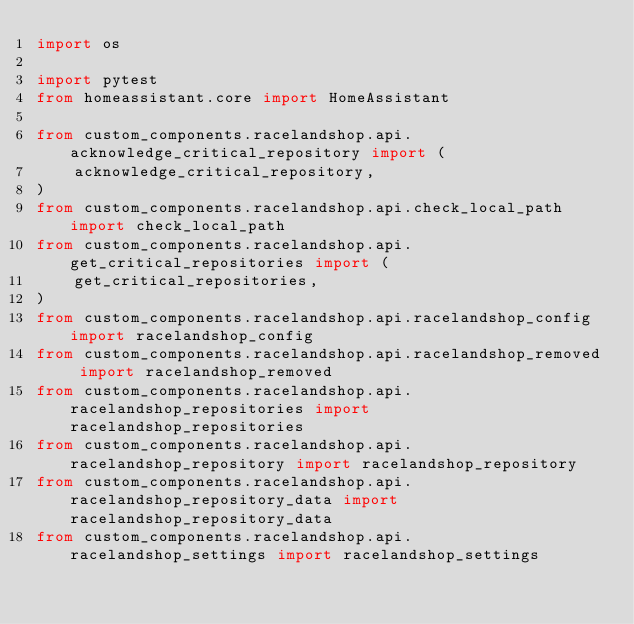<code> <loc_0><loc_0><loc_500><loc_500><_Python_>import os

import pytest
from homeassistant.core import HomeAssistant

from custom_components.racelandshop.api.acknowledge_critical_repository import (
    acknowledge_critical_repository,
)
from custom_components.racelandshop.api.check_local_path import check_local_path
from custom_components.racelandshop.api.get_critical_repositories import (
    get_critical_repositories,
)
from custom_components.racelandshop.api.racelandshop_config import racelandshop_config
from custom_components.racelandshop.api.racelandshop_removed import racelandshop_removed
from custom_components.racelandshop.api.racelandshop_repositories import racelandshop_repositories
from custom_components.racelandshop.api.racelandshop_repository import racelandshop_repository
from custom_components.racelandshop.api.racelandshop_repository_data import racelandshop_repository_data
from custom_components.racelandshop.api.racelandshop_settings import racelandshop_settings</code> 